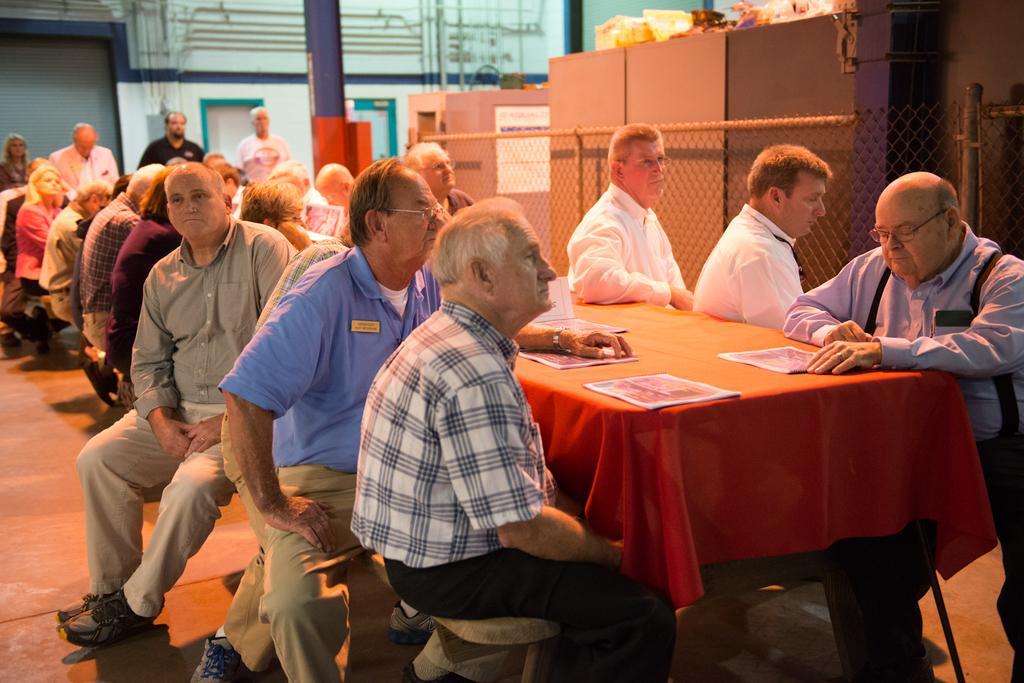Could you give a brief overview of what you see in this image? In this picture we can see persons sitting on chair and in front of them there is table and on table we can see book and in background we can see shutter, pipe, door, fence, boxes and some material. 